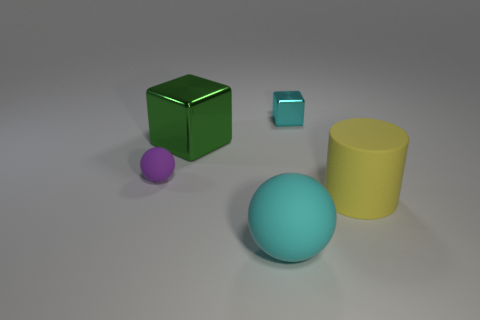Add 2 big red rubber cylinders. How many objects exist? 7 Subtract all cylinders. How many objects are left? 4 Subtract 1 green blocks. How many objects are left? 4 Subtract all big green cubes. Subtract all small red cubes. How many objects are left? 4 Add 2 yellow matte objects. How many yellow matte objects are left? 3 Add 1 small cyan things. How many small cyan things exist? 2 